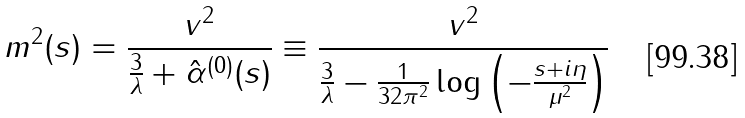Convert formula to latex. <formula><loc_0><loc_0><loc_500><loc_500>m ^ { 2 } ( s ) = \frac { v ^ { 2 } } { \frac { 3 } { \lambda } + \hat { \alpha } ^ { ( 0 ) } ( s ) } \equiv \frac { v ^ { 2 } } { \frac { 3 } { \lambda } - \frac { 1 } { 3 2 \pi ^ { 2 } } \log { \left ( - \frac { s + i \eta } { \mu ^ { 2 } } \right ) } }</formula> 